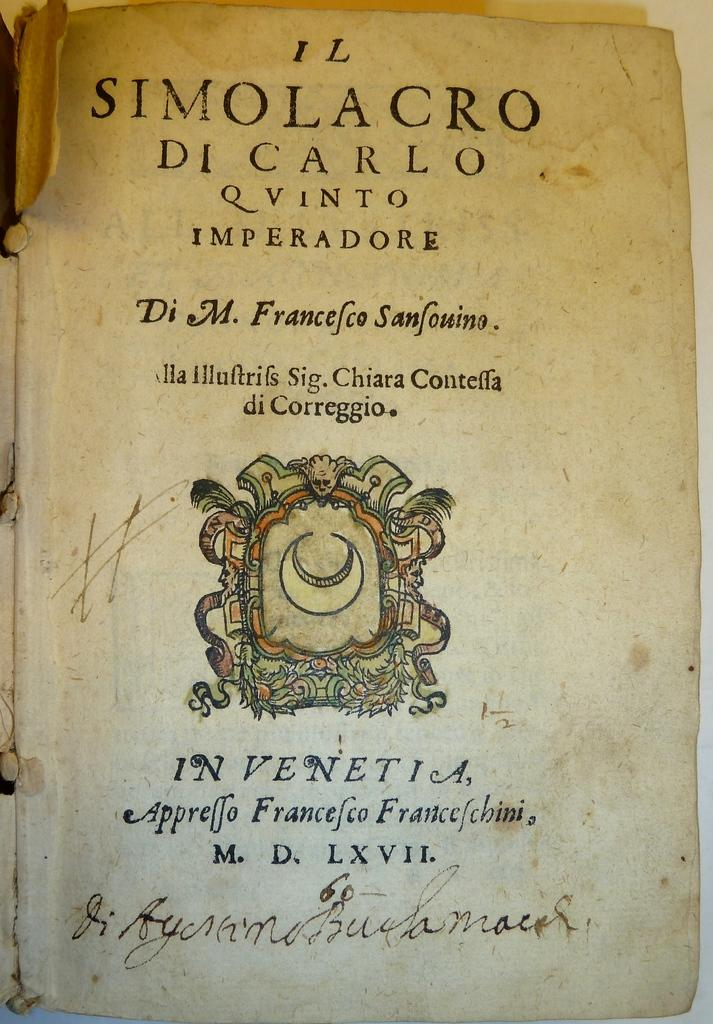Provide a one-sentence caption for the provided image. An old book ripped open to a page called Il Simolacro DI Carlo Q Vinto Imperadore. 